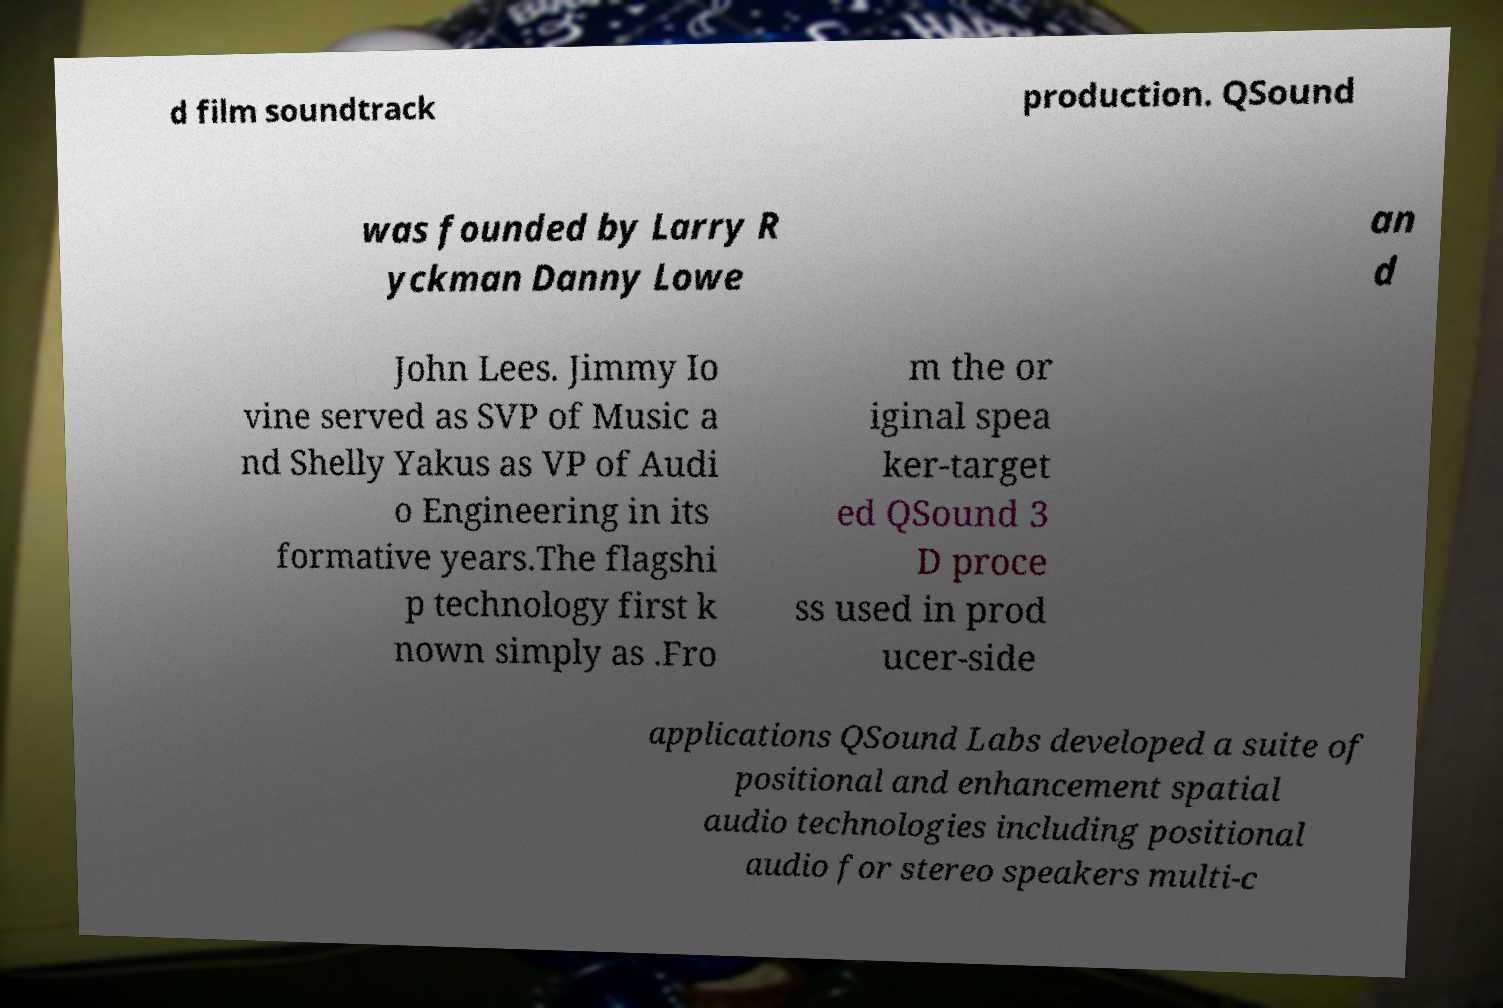There's text embedded in this image that I need extracted. Can you transcribe it verbatim? d film soundtrack production. QSound was founded by Larry R yckman Danny Lowe an d John Lees. Jimmy Io vine served as SVP of Music a nd Shelly Yakus as VP of Audi o Engineering in its formative years.The flagshi p technology first k nown simply as .Fro m the or iginal spea ker-target ed QSound 3 D proce ss used in prod ucer-side applications QSound Labs developed a suite of positional and enhancement spatial audio technologies including positional audio for stereo speakers multi-c 